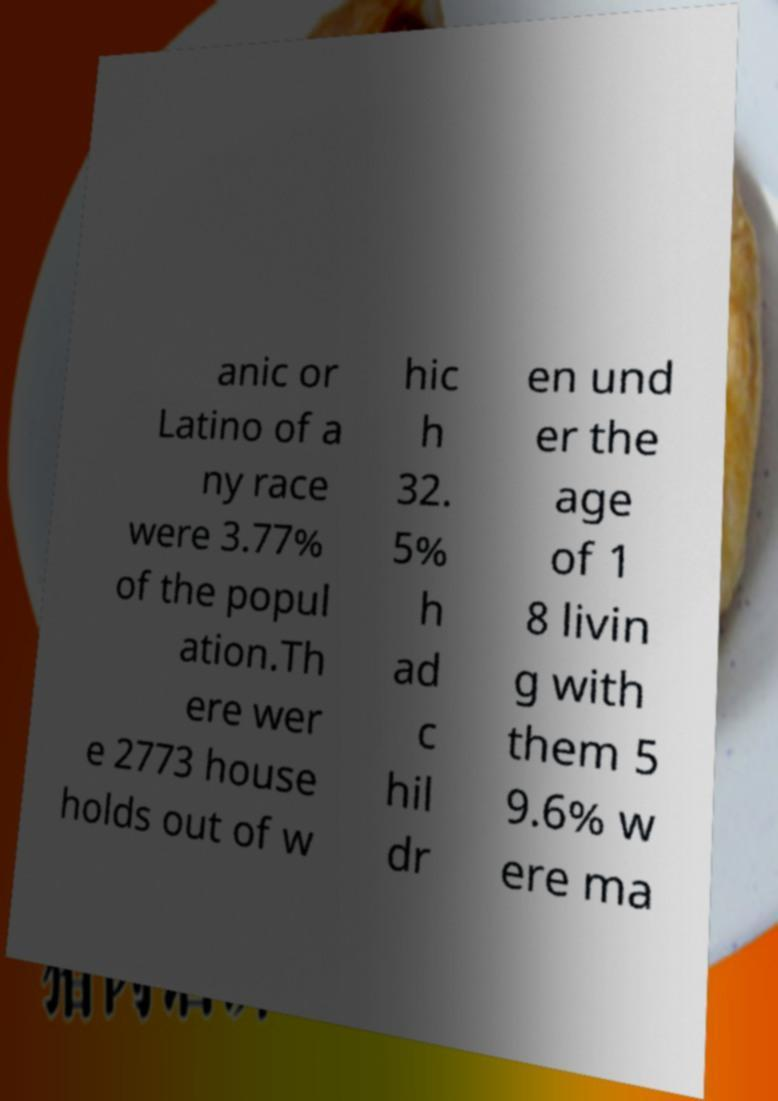I need the written content from this picture converted into text. Can you do that? anic or Latino of a ny race were 3.77% of the popul ation.Th ere wer e 2773 house holds out of w hic h 32. 5% h ad c hil dr en und er the age of 1 8 livin g with them 5 9.6% w ere ma 